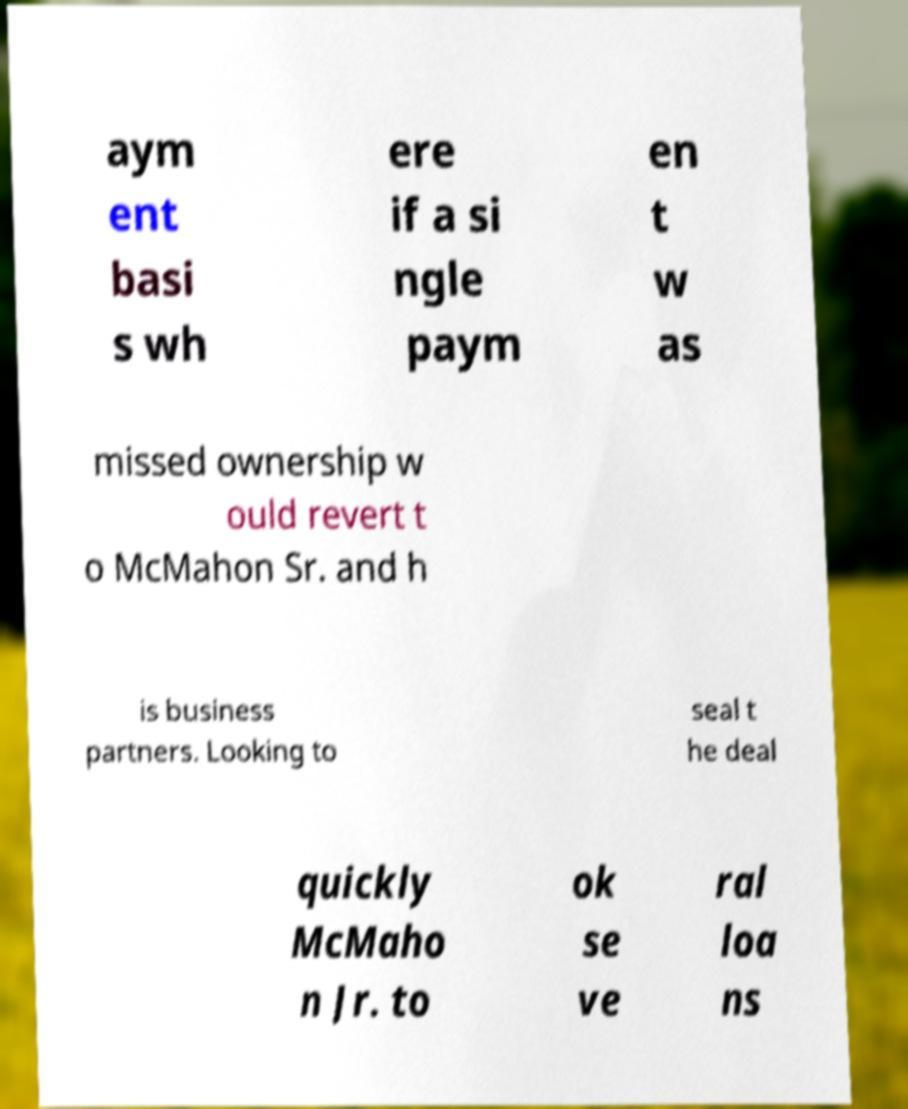What messages or text are displayed in this image? I need them in a readable, typed format. aym ent basi s wh ere if a si ngle paym en t w as missed ownership w ould revert t o McMahon Sr. and h is business partners. Looking to seal t he deal quickly McMaho n Jr. to ok se ve ral loa ns 